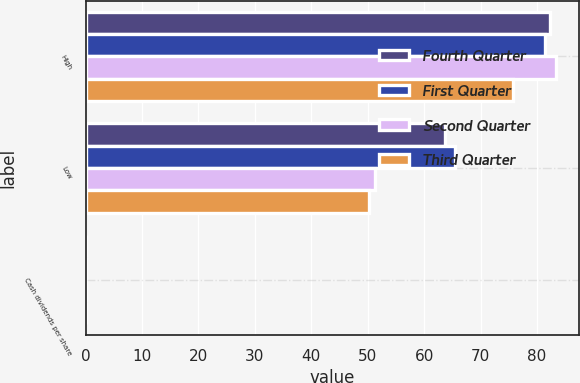Convert chart. <chart><loc_0><loc_0><loc_500><loc_500><stacked_bar_chart><ecel><fcel>High<fcel>Low<fcel>Cash dividends per share<nl><fcel>Fourth Quarter<fcel>82.26<fcel>63.72<fcel>0.11<nl><fcel>First Quarter<fcel>81.46<fcel>65.4<fcel>0.11<nl><fcel>Second Quarter<fcel>83.31<fcel>51.22<fcel>0.11<nl><fcel>Third Quarter<fcel>75.73<fcel>50.23<fcel>0.12<nl></chart> 